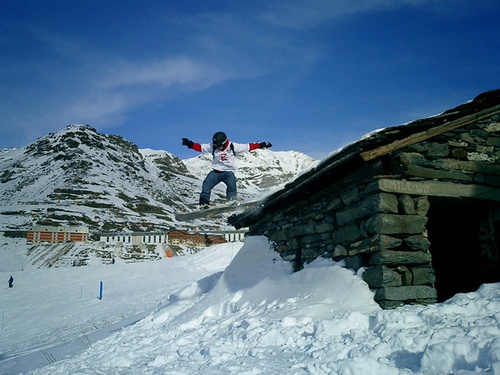Describe the objects in this image and their specific colors. I can see people in navy, black, lightgray, blue, and darkgray tones, snowboard in navy, gray, purple, black, and darkgray tones, and people in navy, black, blue, and gray tones in this image. 